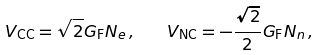Convert formula to latex. <formula><loc_0><loc_0><loc_500><loc_500>V _ { \text {CC} } = \sqrt { 2 } G _ { \text {F} } N _ { e } \, , \quad V _ { \text {NC} } = - \frac { \sqrt { 2 } } { 2 } G _ { \text {F} } N _ { n } \, ,</formula> 